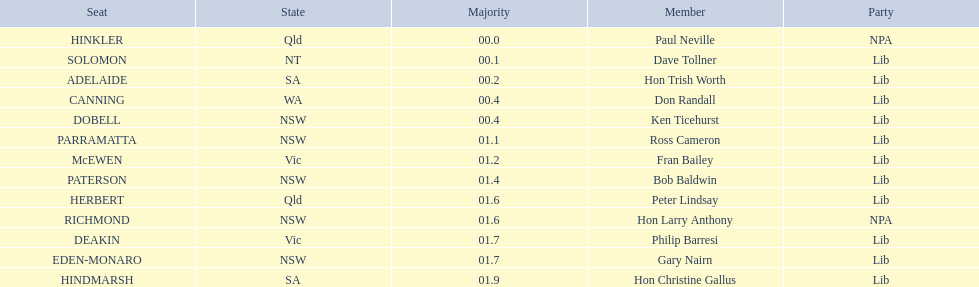In the australian electoral system, which seats are accounted for? HINKLER, SOLOMON, ADELAIDE, CANNING, DOBELL, PARRAMATTA, McEWEN, PATERSON, HERBERT, RICHMOND, DEAKIN, EDEN-MONARO, HINDMARSH. What were the majority counts for both hindmarsh and hinkler? HINKLER, HINDMARSH. Between these two seats, what is the variation in voting majority? 01.9. 